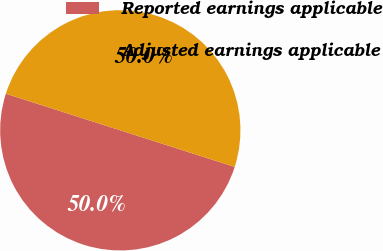<chart> <loc_0><loc_0><loc_500><loc_500><pie_chart><fcel>Reported earnings applicable<fcel>Adjusted earnings applicable<nl><fcel>50.0%<fcel>50.0%<nl></chart> 